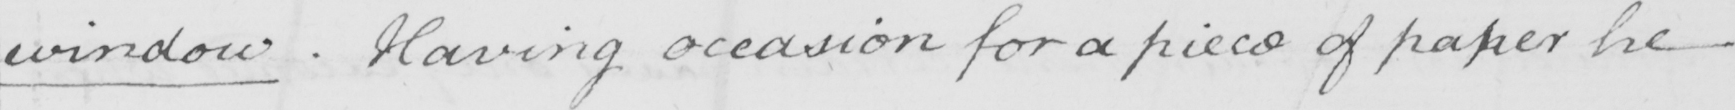Please provide the text content of this handwritten line. window . Having occasion for a piece of paper he 